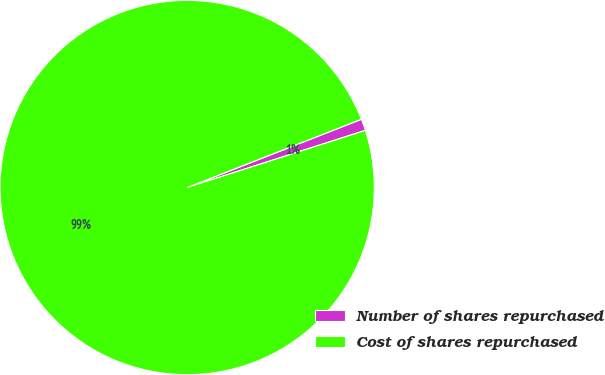Convert chart to OTSL. <chart><loc_0><loc_0><loc_500><loc_500><pie_chart><fcel>Number of shares repurchased<fcel>Cost of shares repurchased<nl><fcel>1.0%<fcel>99.0%<nl></chart> 